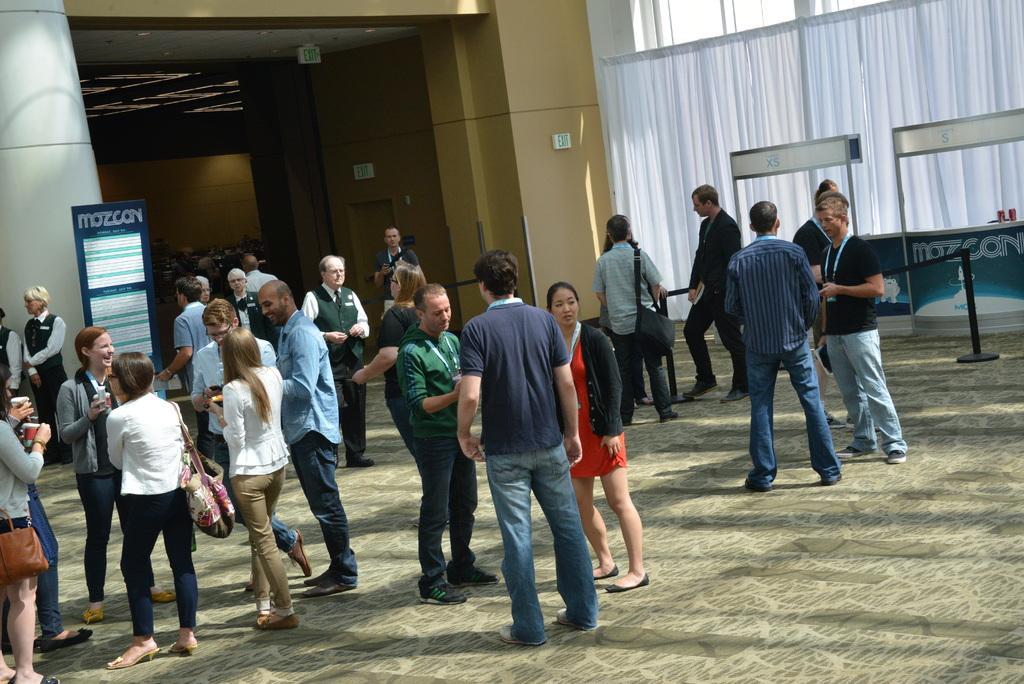Could you give a brief overview of what you see in this image? In this image we can see few persons are standing and among them few persons are carrying bags on their shoulders. In the background we can see a hoarding, rope and pole barrier, curtain, windows, objects, lights on the ceiling and a door. 